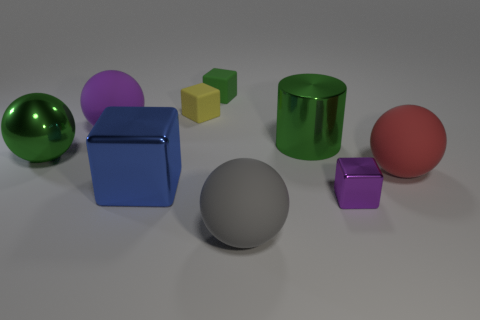Subtract all tiny purple metallic blocks. How many blocks are left? 3 Subtract all green cubes. How many cubes are left? 3 Subtract all cubes. How many objects are left? 5 Subtract 3 balls. How many balls are left? 1 Subtract all metallic blocks. Subtract all big red things. How many objects are left? 6 Add 1 small matte cubes. How many small matte cubes are left? 3 Add 1 big things. How many big things exist? 7 Subtract 0 brown cubes. How many objects are left? 9 Subtract all green balls. Subtract all blue cylinders. How many balls are left? 3 Subtract all brown cylinders. How many red balls are left? 1 